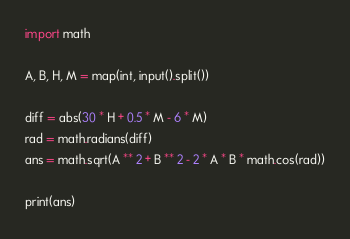Convert code to text. <code><loc_0><loc_0><loc_500><loc_500><_Python_>import math

A, B, H, M = map(int, input().split())

diff = abs(30 * H + 0.5 * M - 6 * M)
rad = math.radians(diff)
ans = math.sqrt(A ** 2 + B ** 2 - 2 * A * B * math.cos(rad))

print(ans)</code> 